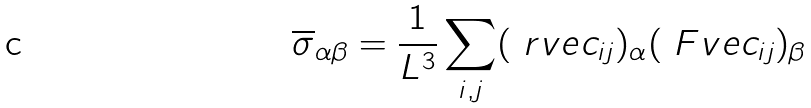Convert formula to latex. <formula><loc_0><loc_0><loc_500><loc_500>\overline { \sigma } _ { \alpha \beta } = \frac { 1 } { L ^ { 3 } } \sum _ { i , j } ( \ r v e c _ { i j } ) _ { \alpha } ( \ F v e c _ { i j } ) _ { \beta }</formula> 